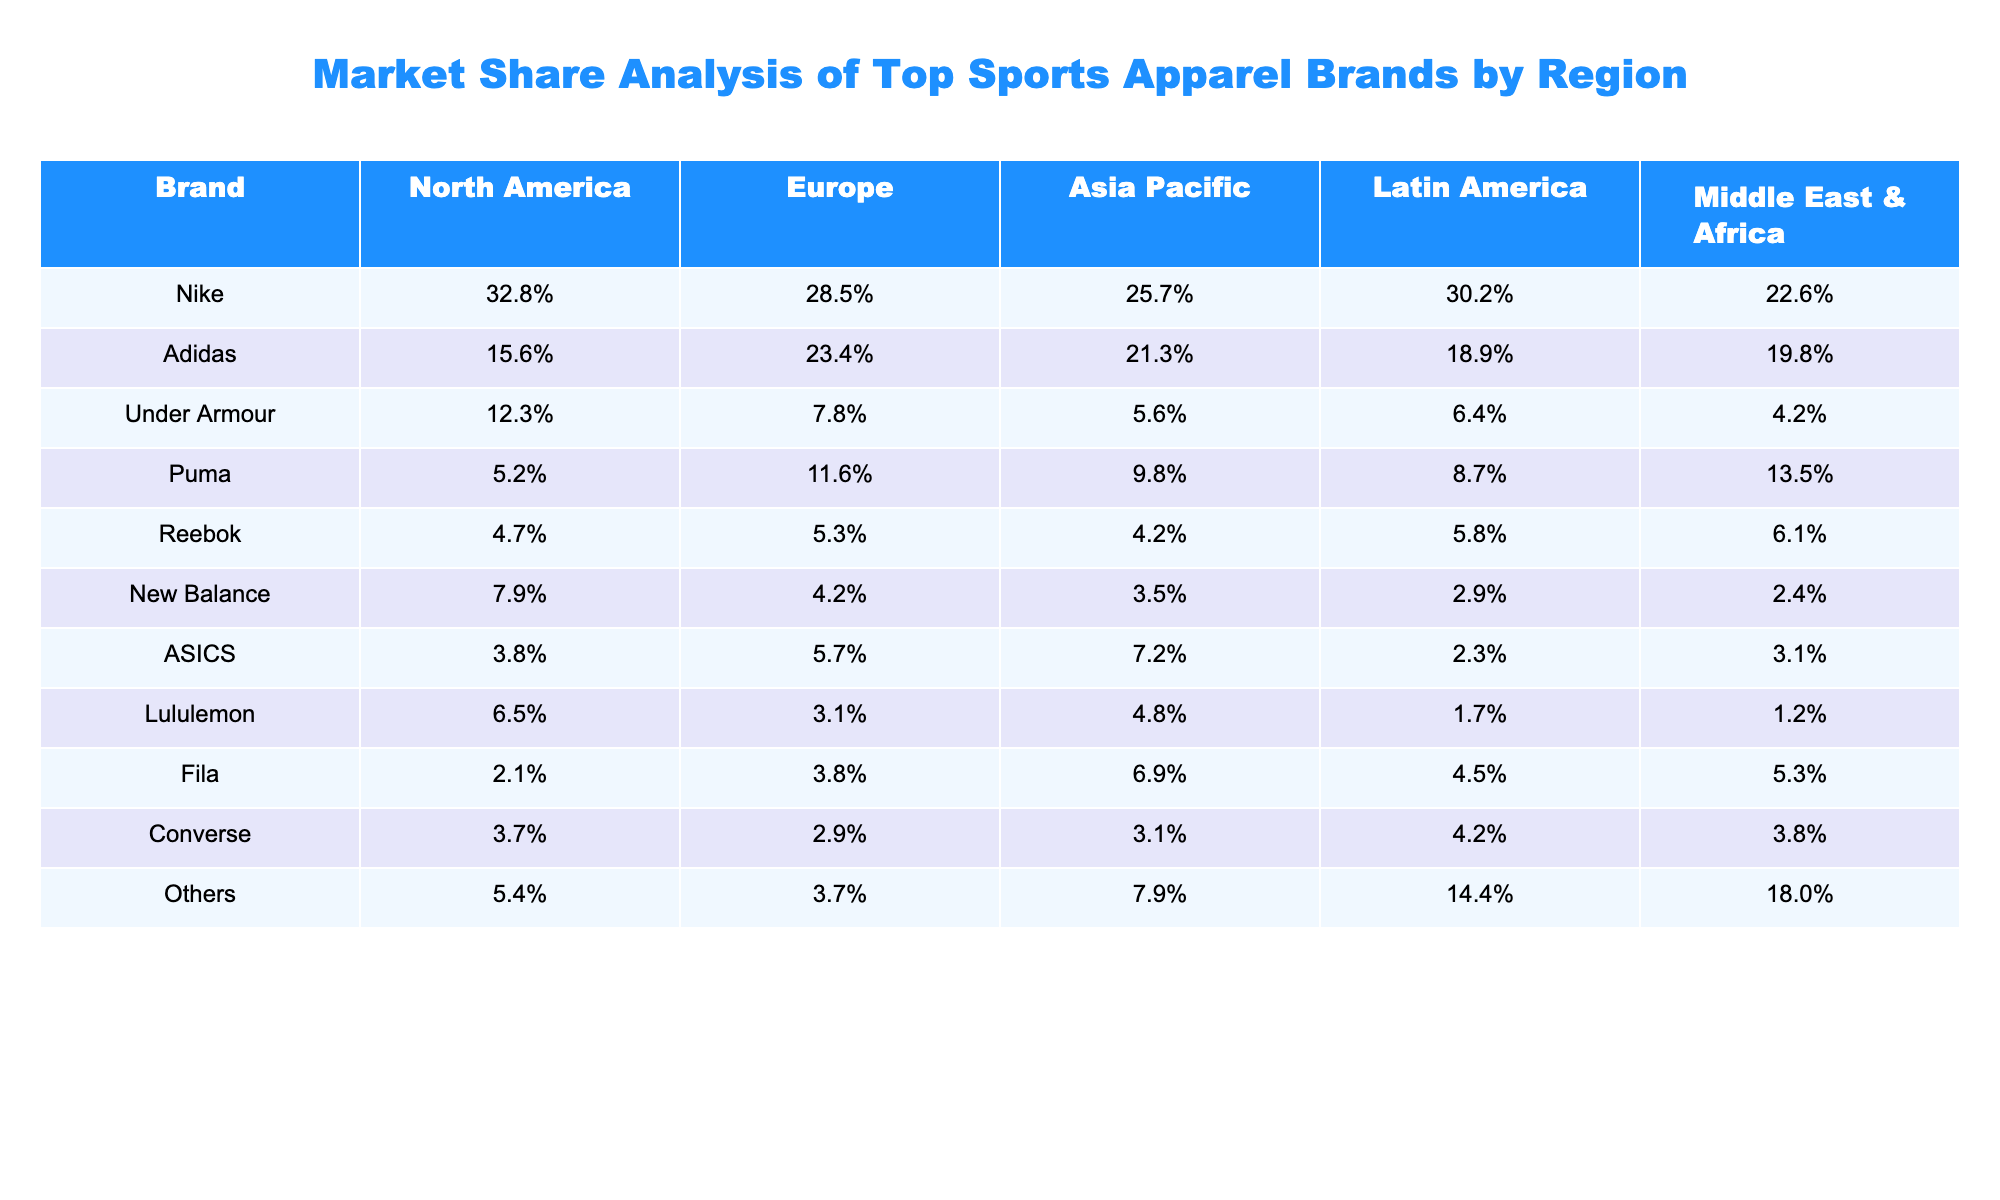What is Nike's market share in North America? Nike's market share in North America is directly listed in the table under the North America column. It shows a value of 32.8%.
Answer: 32.8% Which brand has the highest market share in Europe? The table indicates that Adidas has the highest market share in Europe at 23.4%, as it is the largest percentage in the Europe column.
Answer: Adidas What is the combined market share of Puma and Reebok in Asia Pacific? To find the combined market share, we sum Puma's market share (9.8%) and Reebok's market share (4.2%) in the Asia Pacific column: 9.8% + 4.2% = 14%.
Answer: 14% Is it true that Under Armour’s market share is lower than that of New Balance in all regions? We evaluate Under Armour and New Balance's market shares across all regions and find that Under Armour has a lower percentage than New Balance in the North America (12.3% < 7.9%) and Europe (7.8% < 4.2%) columns, making the statement false in those regions.
Answer: False What is the average market share of the brand 'Others' across all regions? To calculate the average market share, we add the percentages for 'Others' from all regions: 5.4% + 3.7% + 7.9% + 14.4% + 18.0% = 49.4%, then divide by the number of regions (5), resulting in an average of 49.4% / 5 = 9.88%.
Answer: 9.88% Which region shows the lowest market share for Adidas? By checking each region in the table, Adidas has a market share of 15.6% in North America, 23.4% in Europe, 21.3% in Asia Pacific, 18.9% in Latin America, and 19.8% in the Middle East & Africa. The lowest value is found in North America.
Answer: North America How much higher is Nike's market share in North America compared to its market share in the Middle East & Africa? We assess Nike's market shares in both regions: North America has 32.8% and Middle East & Africa has 22.6%. The difference is calculated as 32.8% - 22.6% = 10.2%.
Answer: 10.2% What percentage of the market share in Latin America does Lululemon hold? The table specifies Lululemon's market share in Latin America as 1.7%.
Answer: 1.7% If we combine the market shares of all brands except for Nike in the Asia Pacific region, what would we find? We calculate by adding Adidas (21.3%), Under Armour (5.6%), Puma (9.8%), Reebok (4.2%), New Balance (3.5%), ASICS (7.2%), Lululemon (4.8%), Fila (6.9%), Converse (3.1%), and Others (7.9%) together, resulting in 21.3% + 5.6% + 9.8% + 4.2% + 3.5% + 7.2% + 4.8% + 6.9% + 3.1% + 7.9% = 74.3%.
Answer: 74.3% Is the market share of 'Others' in the Middle East & Africa greater than that of Puma? We check both values in the Middle East & Africa column, where 'Others' has 18.0% and Puma has 13.5%. Since 18.0% is greater than 13.5%, the answer to the question is true.
Answer: True 